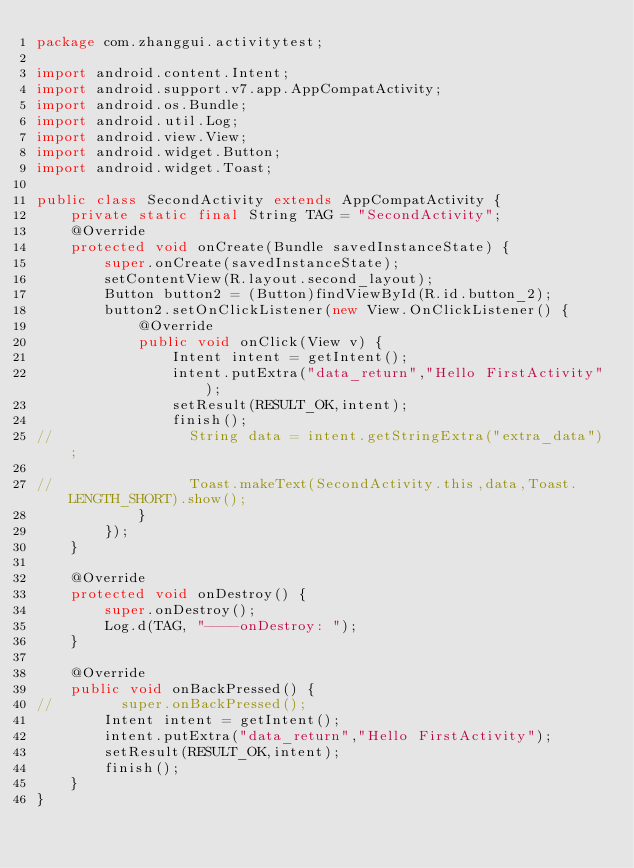Convert code to text. <code><loc_0><loc_0><loc_500><loc_500><_Java_>package com.zhanggui.activitytest;

import android.content.Intent;
import android.support.v7.app.AppCompatActivity;
import android.os.Bundle;
import android.util.Log;
import android.view.View;
import android.widget.Button;
import android.widget.Toast;

public class SecondActivity extends AppCompatActivity {
    private static final String TAG = "SecondActivity";
    @Override
    protected void onCreate(Bundle savedInstanceState) {
        super.onCreate(savedInstanceState);
        setContentView(R.layout.second_layout);
        Button button2 = (Button)findViewById(R.id.button_2);
        button2.setOnClickListener(new View.OnClickListener() {
            @Override
            public void onClick(View v) {
                Intent intent = getIntent();
                intent.putExtra("data_return","Hello FirstActivity");
                setResult(RESULT_OK,intent);
                finish();
//                String data = intent.getStringExtra("extra_data");

//                Toast.makeText(SecondActivity.this,data,Toast.LENGTH_SHORT).show();
            }
        });
    }

    @Override
    protected void onDestroy() {
        super.onDestroy();
        Log.d(TAG, "----onDestroy: ");
    }

    @Override
    public void onBackPressed() {
//        super.onBackPressed();
        Intent intent = getIntent();
        intent.putExtra("data_return","Hello FirstActivity");
        setResult(RESULT_OK,intent);
        finish();
    }
}
</code> 